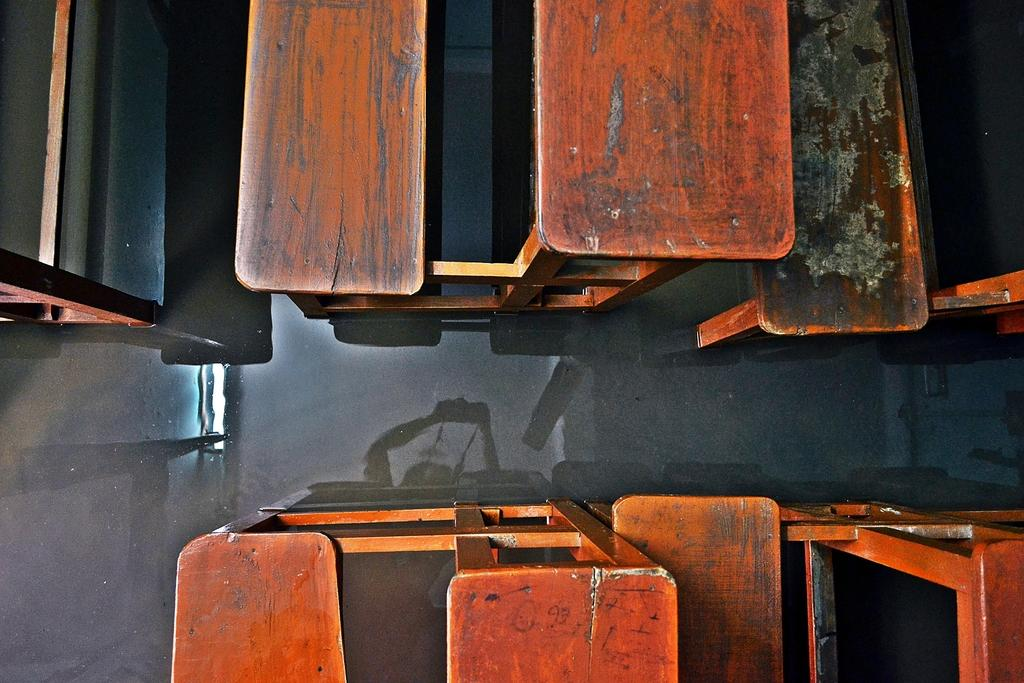What objects are placed on the floor in the image? There are benches on the floor in the image. How many benches can be seen in the image? The image only shows benches placed on the floor. What book is the baby reading on the bench in the image? There is no baby or book present in the image; it only shows benches on the floor. What type of collar is visible on the bench in the image? There is no collar present in the image; it only shows benches on the floor. 